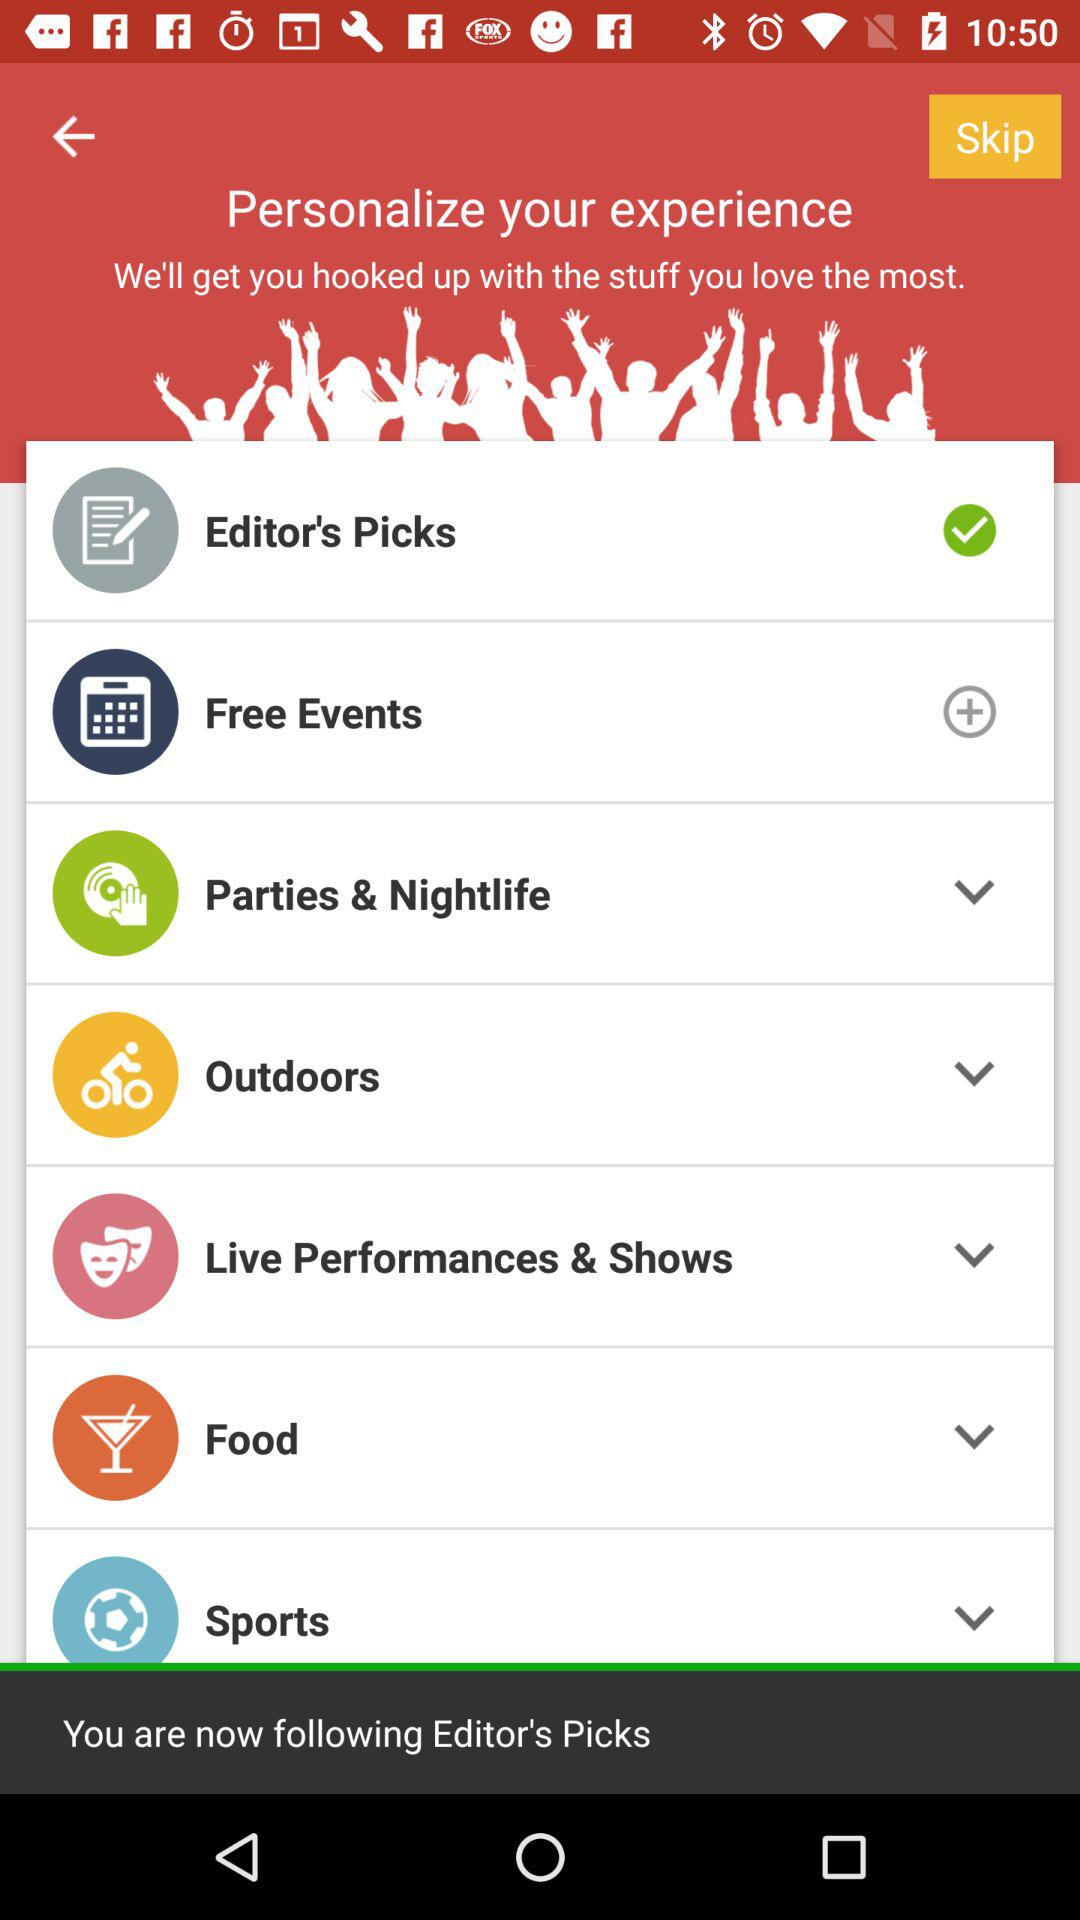Whom am I now beginning to follow? You are now beginning to follow "Editor's Picks". 